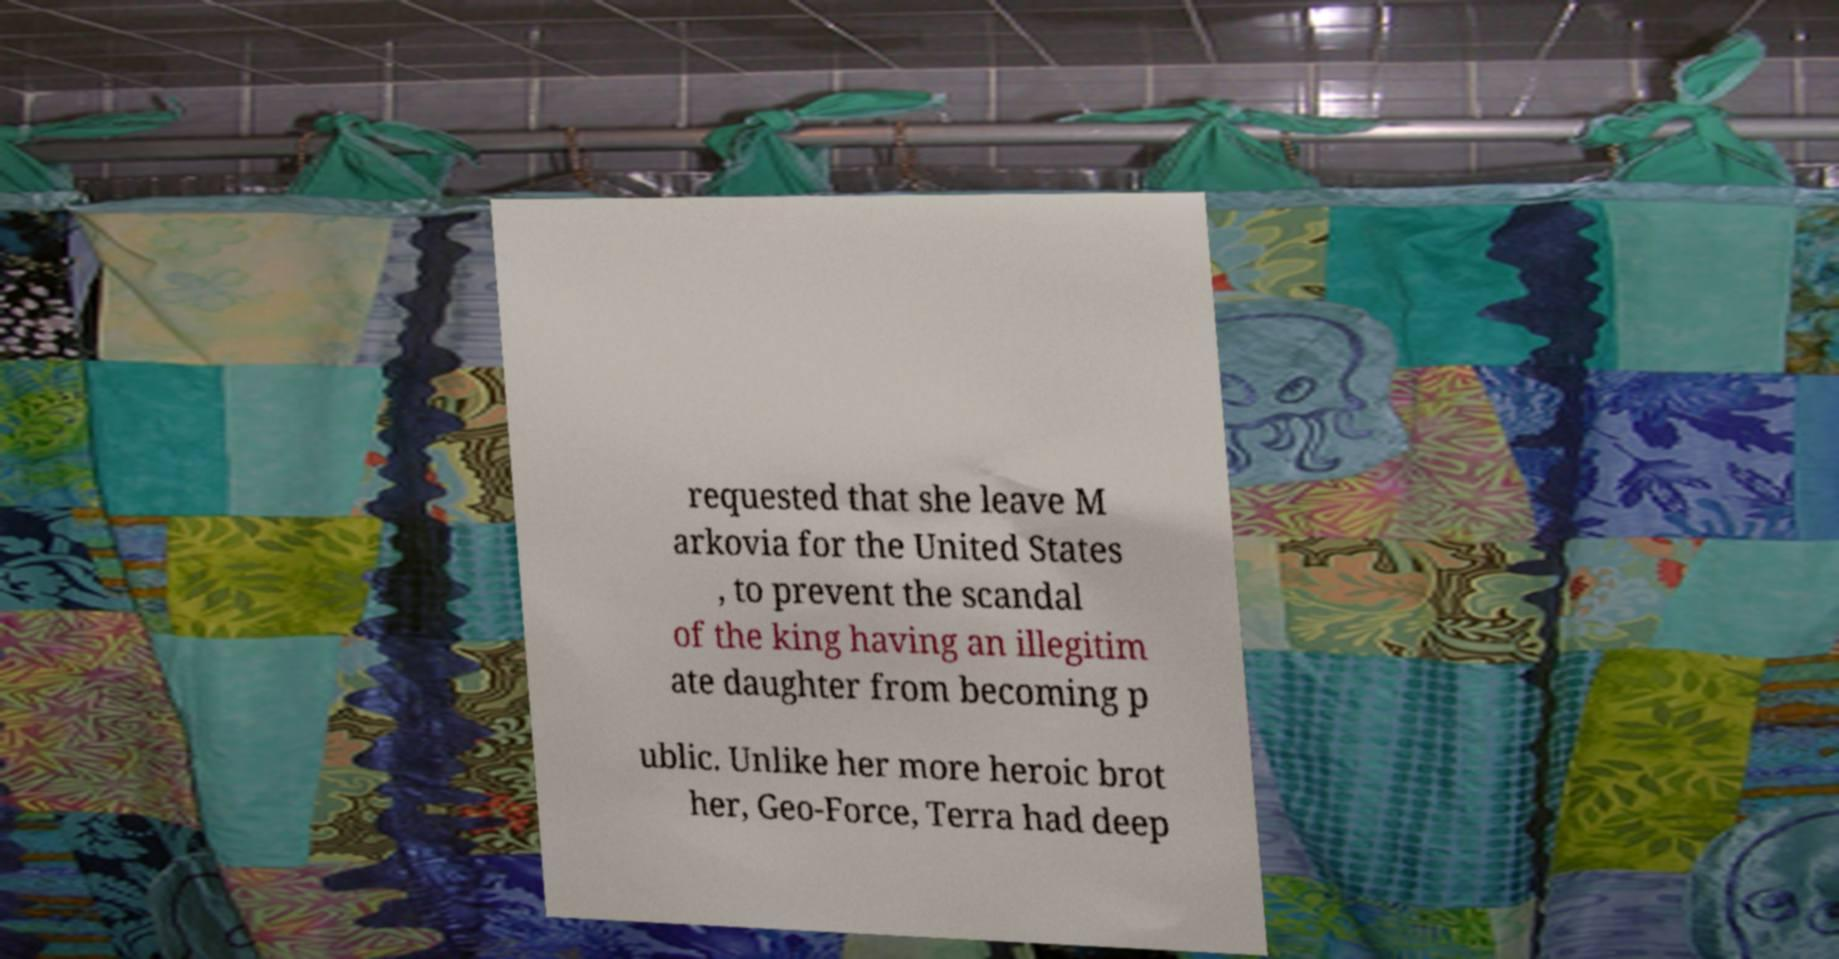There's text embedded in this image that I need extracted. Can you transcribe it verbatim? requested that she leave M arkovia for the United States , to prevent the scandal of the king having an illegitim ate daughter from becoming p ublic. Unlike her more heroic brot her, Geo-Force, Terra had deep 